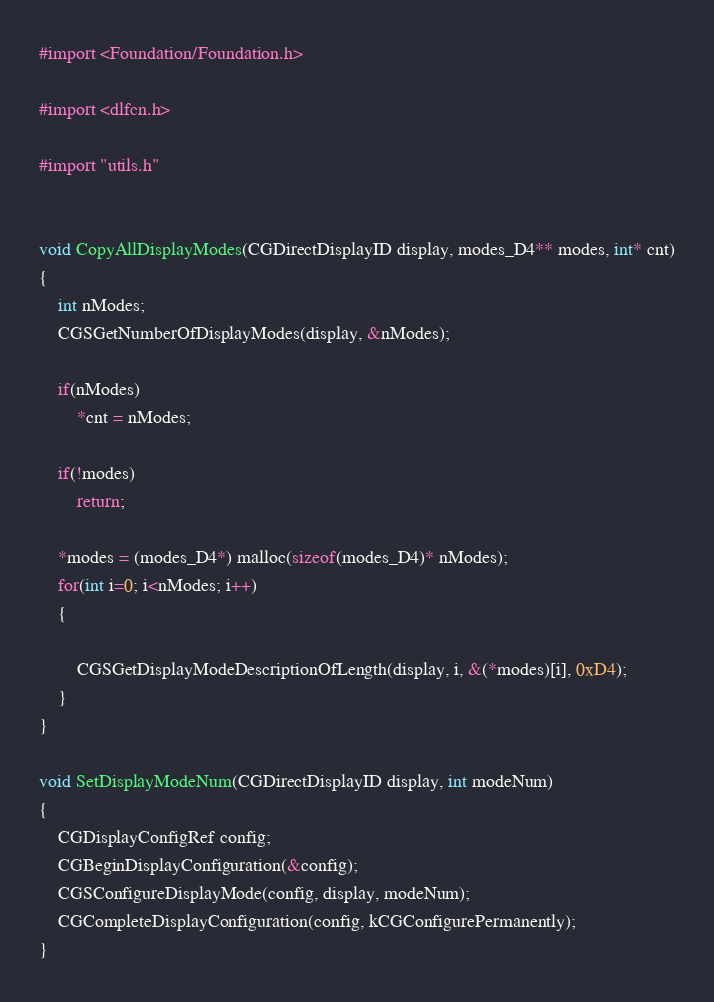<code> <loc_0><loc_0><loc_500><loc_500><_ObjectiveC_>
#import <Foundation/Foundation.h>

#import <dlfcn.h>

#import "utils.h"


void CopyAllDisplayModes(CGDirectDisplayID display, modes_D4** modes, int* cnt)
{
	int nModes;
	CGSGetNumberOfDisplayModes(display, &nModes);
	
	if(nModes)
		*cnt = nModes;
	
	if(!modes)
		return;
		
	*modes = (modes_D4*) malloc(sizeof(modes_D4)* nModes);
	for(int i=0; i<nModes; i++)
	{
		
		CGSGetDisplayModeDescriptionOfLength(display, i, &(*modes)[i], 0xD4);
	}
}

void SetDisplayModeNum(CGDirectDisplayID display, int modeNum)
{
	CGDisplayConfigRef config;
	CGBeginDisplayConfiguration(&config);
	CGSConfigureDisplayMode(config, display, modeNum);
	CGCompleteDisplayConfiguration(config, kCGConfigurePermanently);
}</code> 